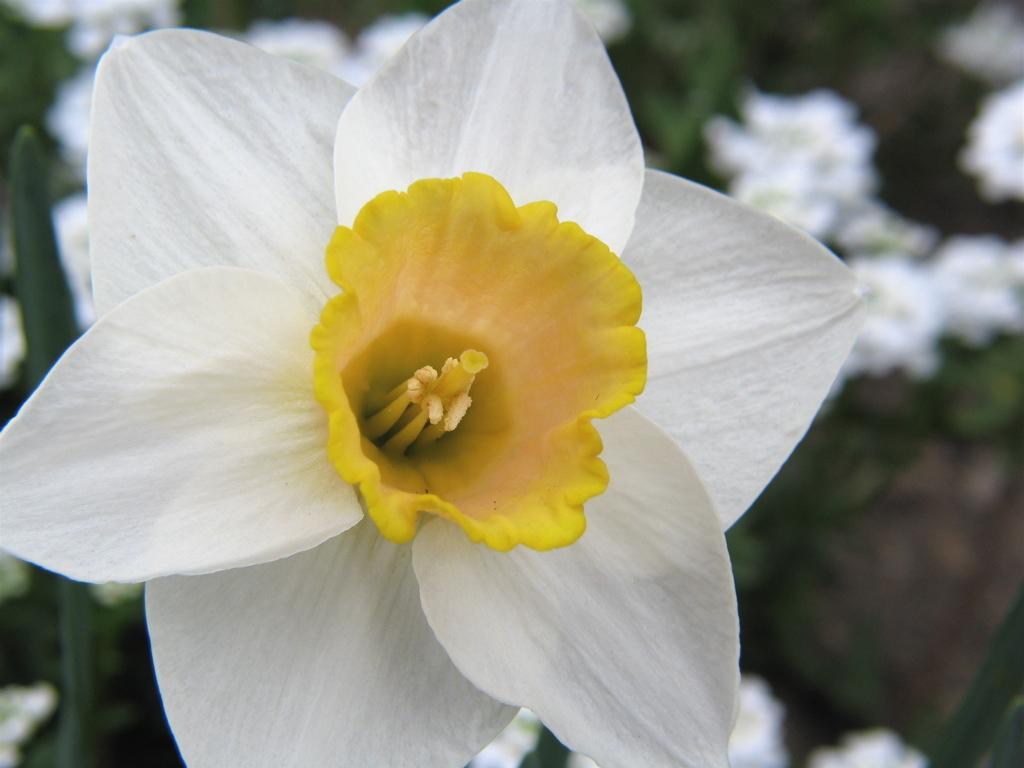How would you summarize this image in a sentence or two? In the image there is a flower with white petals and there is another yellow flower in between the petals, the background of the flower is blur. 